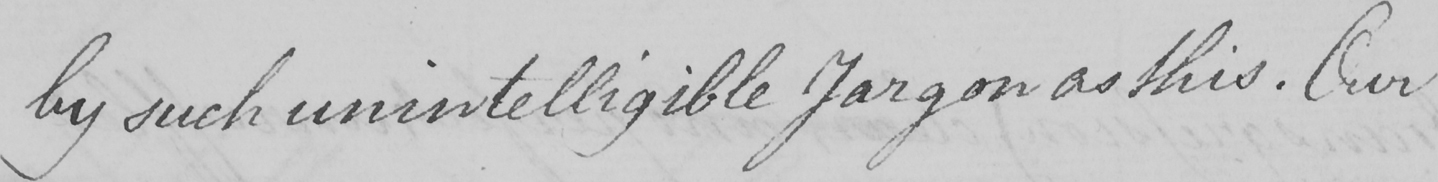What text is written in this handwritten line? by such unintelligible Jargon as this . Our 